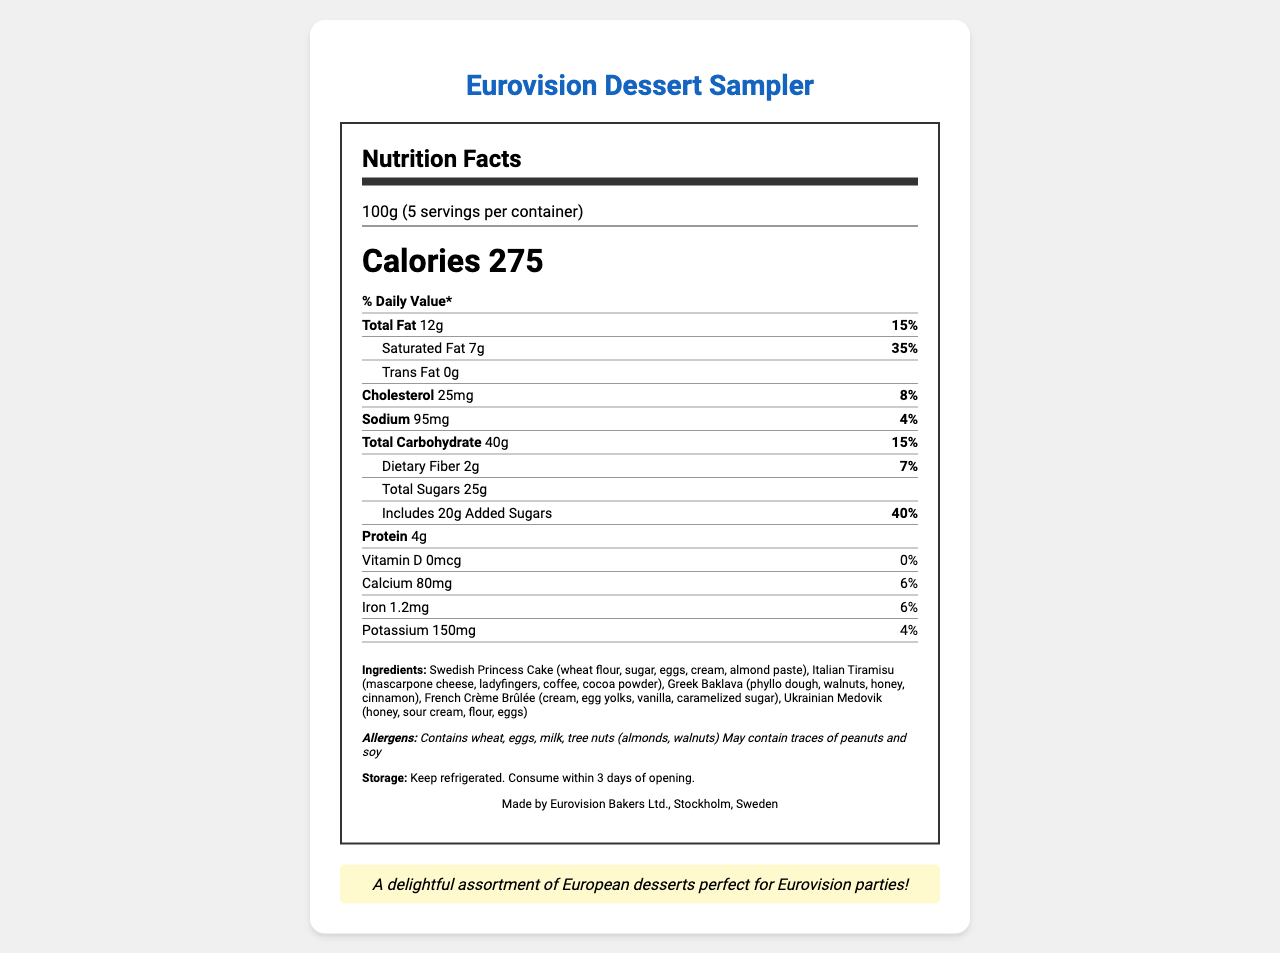what is the serving size? The serving size is explicitly mentioned at the top of the nutrition label as "100g".
Answer: 100g how many calories are there per serving? The calories per serving are listed in large, bold font as "Calories 275".
Answer: 275 what is the percentage daily value of saturated fat? The saturated fat section shows "7g" with "35%" right next to it, indicating the daily value percentage.
Answer: 35% how much dietary fiber does one serving contain? The dietary fiber content is listed as "2g".
Answer: 2g which type of fat has no quantity listed? A. Total Fat B. Saturated Fat C. Trans Fat D. Monounsaturated Fat The document lists quantities for total fat, saturated fat, and trans fat, but not monounsaturated fat.
Answer: D how much protein is there in one serving? The protein content is indicated as "4g".
Answer: 4g does the sampler contain any added sugars? The document includes a section for added sugars that shows an amount of "20g" and a daily value percentage of "40%".
Answer: Yes what allergens are mentioned? A section labeled "Allergens" lists these specific allergens.
Answer: Wheat, eggs, milk, tree nuts (almonds, walnuts), traces of peanuts and soy according to the document, which nutrient has the highest percentage daily value? A. Cholesterol B. Calcium C. Saturated Fat D. Iron Saturated fat has the highest percentage daily value at "35%", compared to cholesterol (8%), calcium (6%), and iron (6%).
Answer: C where should the Eurovision Dessert Sampler be stored? The storage instructions specify "Keep refrigerated."
Answer: Refrigerated what is the total sugar content per serving? The total sugar, listed under total carbohydrate, is "25g".
Answer: 25g describe the main idea of the document. The document provides an overview of the nutritional content and other relevant details about the Eurovision Dessert Sampler, which includes a variety of European desserts.
Answer: The document is a nutrition facts label for a Eurovision Dessert Sampler that details serving size, calories, various nutrients, ingredients, allergens, storage instructions, and manufacturer information. what kind of cheese is used in the Italian Tiramisu? The ingredients section lists mascarpone cheese for the Italian Tiramisu.
Answer: Mascarpone what is the amount of iron per serving? Iron content is listed as "1.2mg".
Answer: 1.2mg can we determine the manufacturing date from the document? The document does not provide any information regarding the manufacturing date.
Answer: No 